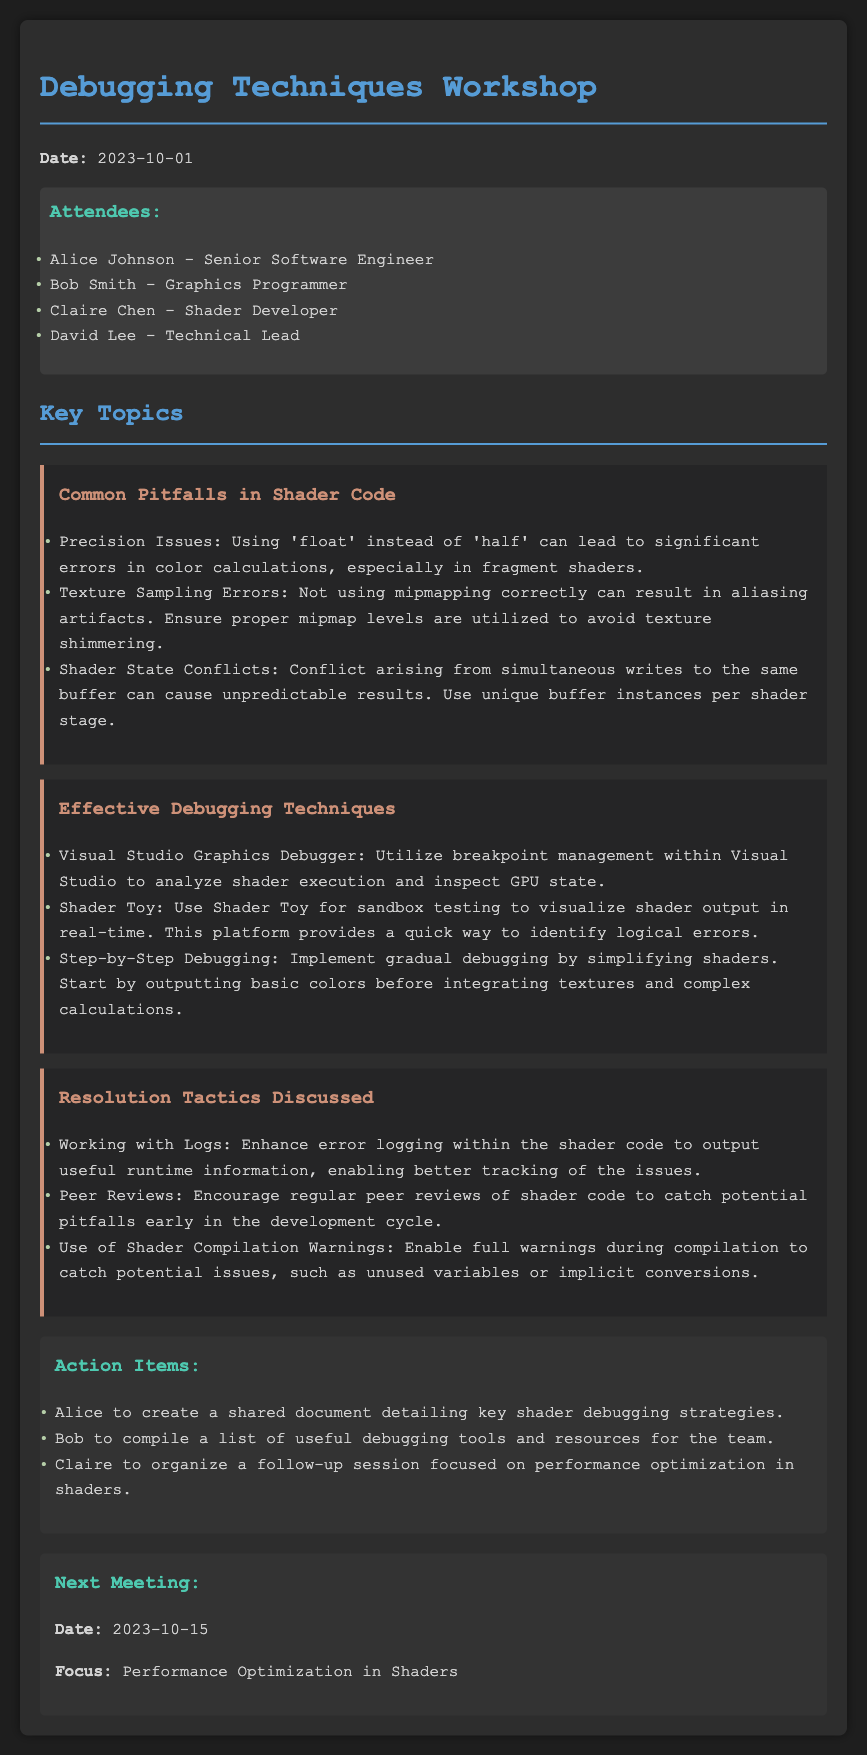What date was the workshop held? The date is explicitly stated at the beginning of the document as the occurrence date of the meeting.
Answer: 2023-10-01 Who is the Technical Lead that attended the workshop? The document includes a list of attendees and identifies David in the role of Technical Lead.
Answer: David Lee What is one common pitfall mentioned regarding shader code? The document outlines multiple pitfalls, one of which highlights precision issues especially relevant to fragment shaders.
Answer: Precision Issues What debugging tool was suggested for visualizing shader output? The document mentions a specific tool that can be used to visualize shader output in real-time, indicating its purpose in testing.
Answer: Shader Toy What is the subject of the next meeting? The next meeting's focus is specified at the end of the document, detailing what will be discussed.
Answer: Performance Optimization in Shaders Which action item involves creating a shared document? An action item is directly referenced within the document that states who will create the document and its purpose.
Answer: Alice In what context should shader compilation warnings be used? The document advises on enabling warnings during compilation to catch various issues, which indicates the importance of oversight in development.
Answer: To catch potential issues How many attendees are listed in the document? The list of attendees can be counted directly from the document, providing a precise total number of participants.
Answer: Four 